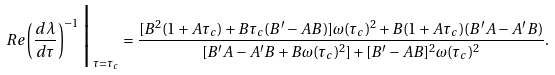Convert formula to latex. <formula><loc_0><loc_0><loc_500><loc_500>R e \left ( \frac { d \lambda } { d \tau } \right ) ^ { - 1 } \Big | _ { \tau = \tau _ { c } } = \frac { [ B ^ { 2 } ( 1 + A \tau _ { c } ) + B \tau _ { c } ( B ^ { \prime } - A B ) ] \omega ( \tau _ { c } ) ^ { 2 } + B ( 1 + A \tau _ { c } ) ( B ^ { \prime } A - A ^ { \prime } B ) } { [ B ^ { \prime } A - A ^ { \prime } B + B \omega ( \tau _ { c } ) ^ { 2 } ] + [ B ^ { \prime } - A B ] ^ { 2 } \omega ( \tau _ { c } ) ^ { 2 } } .</formula> 